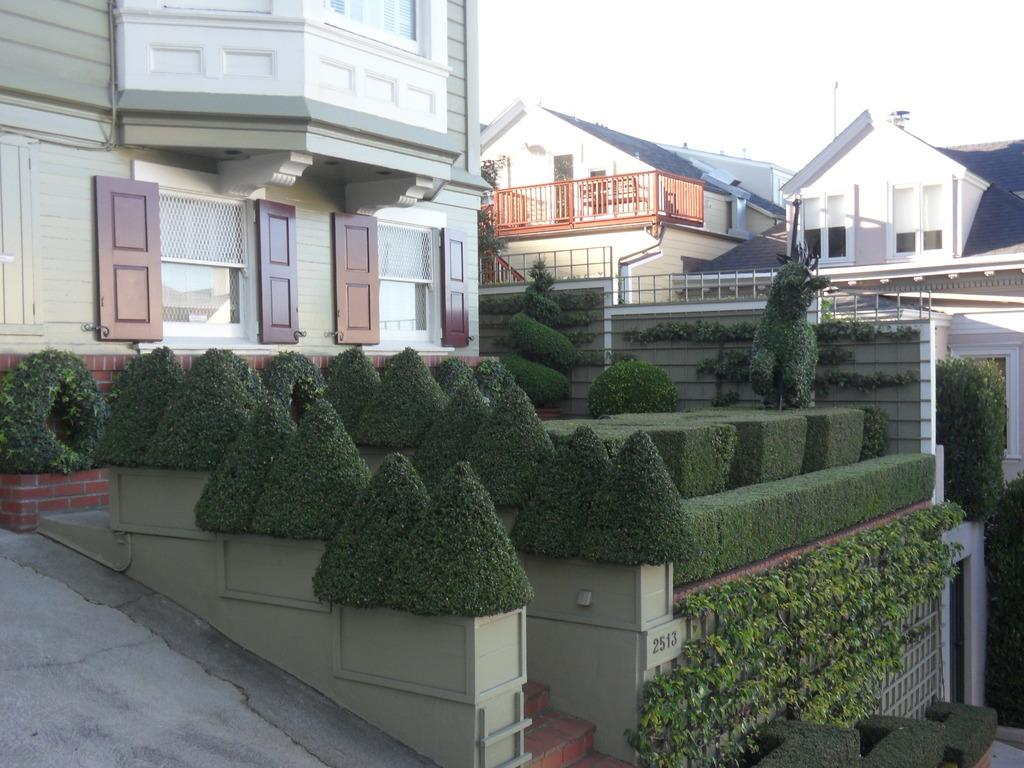What type of structures can be seen in the image? There are houses in the image. What type of vegetation is present in the image? There are bushes in the image. What object with numbers can be seen in the image? There is a board with numbers in the image. What architectural feature is visible in the image? There are steps in the image. What type of surface is present in the image? There is a path in the image. What can be seen in the background of the image? The sky is visible in the background of the image. What flavor of ice cream is the father eating in the image? There is no ice cream or father present in the image. What type of sun is visible in the image? There is no sun present in the image; only the sky is visible in the background. 